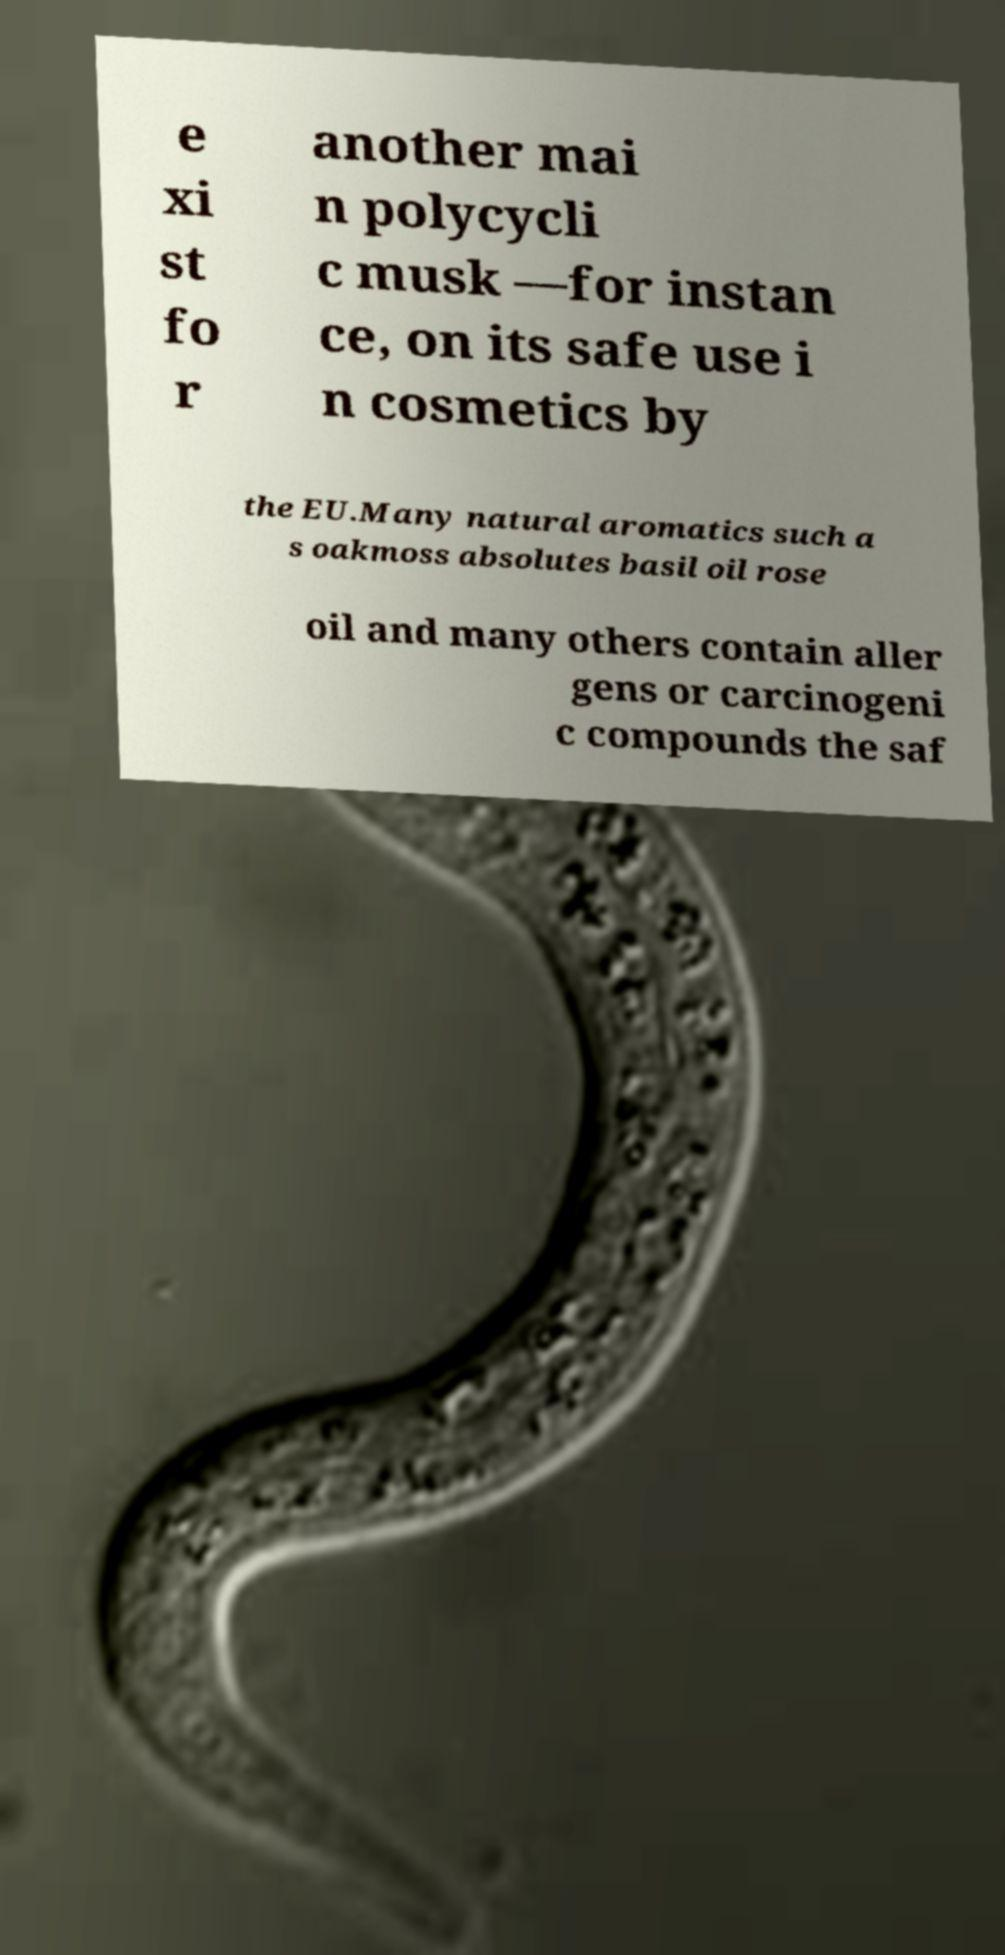What messages or text are displayed in this image? I need them in a readable, typed format. e xi st fo r another mai n polycycli c musk —for instan ce, on its safe use i n cosmetics by the EU.Many natural aromatics such a s oakmoss absolutes basil oil rose oil and many others contain aller gens or carcinogeni c compounds the saf 